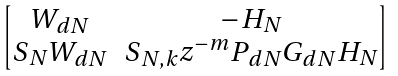<formula> <loc_0><loc_0><loc_500><loc_500>\begin{bmatrix} W _ { d N } & - H _ { N } \\ S _ { N } W _ { d N } & S _ { N , k } z ^ { - m } P _ { d N } G _ { d N } H _ { N } \end{bmatrix}</formula> 